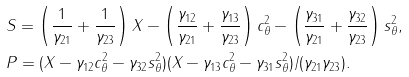<formula> <loc_0><loc_0><loc_500><loc_500>& S = \left ( \frac { 1 } { \gamma _ { 2 1 } } + \frac { 1 } { \gamma _ { 2 3 } } \right ) X - \left ( \frac { \gamma _ { 1 2 } } { \gamma _ { 2 1 } } + \frac { \gamma _ { 1 3 } } { \gamma _ { 2 3 } } \right ) c _ { \theta } ^ { 2 } - \left ( \frac { \gamma _ { 3 1 } } { \gamma _ { 2 1 } } + \frac { \gamma _ { 3 2 } } { \gamma _ { 2 3 } } \right ) s _ { \theta } ^ { 2 } , \\ & P = ( X - \gamma _ { 1 2 } c _ { \theta } ^ { 2 } - \gamma _ { 3 2 } s _ { \theta } ^ { 2 } ) ( X - \gamma _ { 1 3 } c _ { \theta } ^ { 2 } - \gamma _ { 3 1 } s _ { \theta } ^ { 2 } ) / ( \gamma _ { 2 1 } \gamma _ { 2 3 } ) .</formula> 